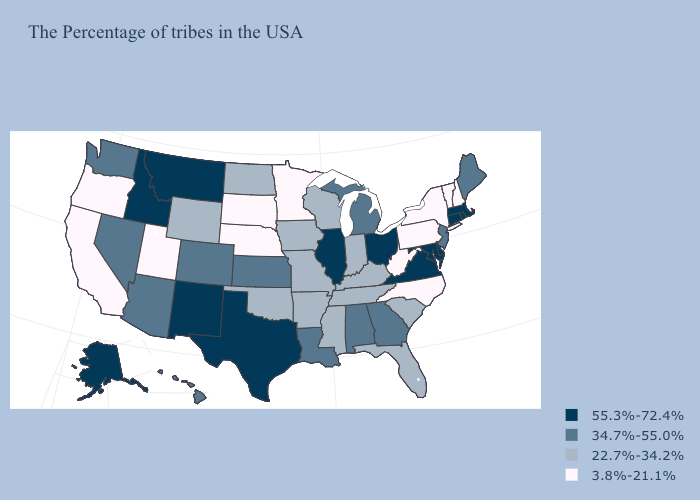What is the lowest value in the Northeast?
Give a very brief answer. 3.8%-21.1%. Name the states that have a value in the range 3.8%-21.1%?
Quick response, please. New Hampshire, Vermont, New York, Pennsylvania, North Carolina, West Virginia, Minnesota, Nebraska, South Dakota, Utah, California, Oregon. Name the states that have a value in the range 34.7%-55.0%?
Quick response, please. Maine, New Jersey, Georgia, Michigan, Alabama, Louisiana, Kansas, Colorado, Arizona, Nevada, Washington, Hawaii. What is the value of Ohio?
Concise answer only. 55.3%-72.4%. Is the legend a continuous bar?
Answer briefly. No. Name the states that have a value in the range 3.8%-21.1%?
Give a very brief answer. New Hampshire, Vermont, New York, Pennsylvania, North Carolina, West Virginia, Minnesota, Nebraska, South Dakota, Utah, California, Oregon. What is the highest value in states that border Maine?
Quick response, please. 3.8%-21.1%. Name the states that have a value in the range 55.3%-72.4%?
Give a very brief answer. Massachusetts, Rhode Island, Connecticut, Delaware, Maryland, Virginia, Ohio, Illinois, Texas, New Mexico, Montana, Idaho, Alaska. What is the value of Maryland?
Concise answer only. 55.3%-72.4%. Name the states that have a value in the range 3.8%-21.1%?
Short answer required. New Hampshire, Vermont, New York, Pennsylvania, North Carolina, West Virginia, Minnesota, Nebraska, South Dakota, Utah, California, Oregon. What is the value of Oklahoma?
Short answer required. 22.7%-34.2%. Name the states that have a value in the range 3.8%-21.1%?
Write a very short answer. New Hampshire, Vermont, New York, Pennsylvania, North Carolina, West Virginia, Minnesota, Nebraska, South Dakota, Utah, California, Oregon. Does Wyoming have the highest value in the West?
Quick response, please. No. What is the lowest value in the Northeast?
Quick response, please. 3.8%-21.1%. What is the value of Florida?
Quick response, please. 22.7%-34.2%. 